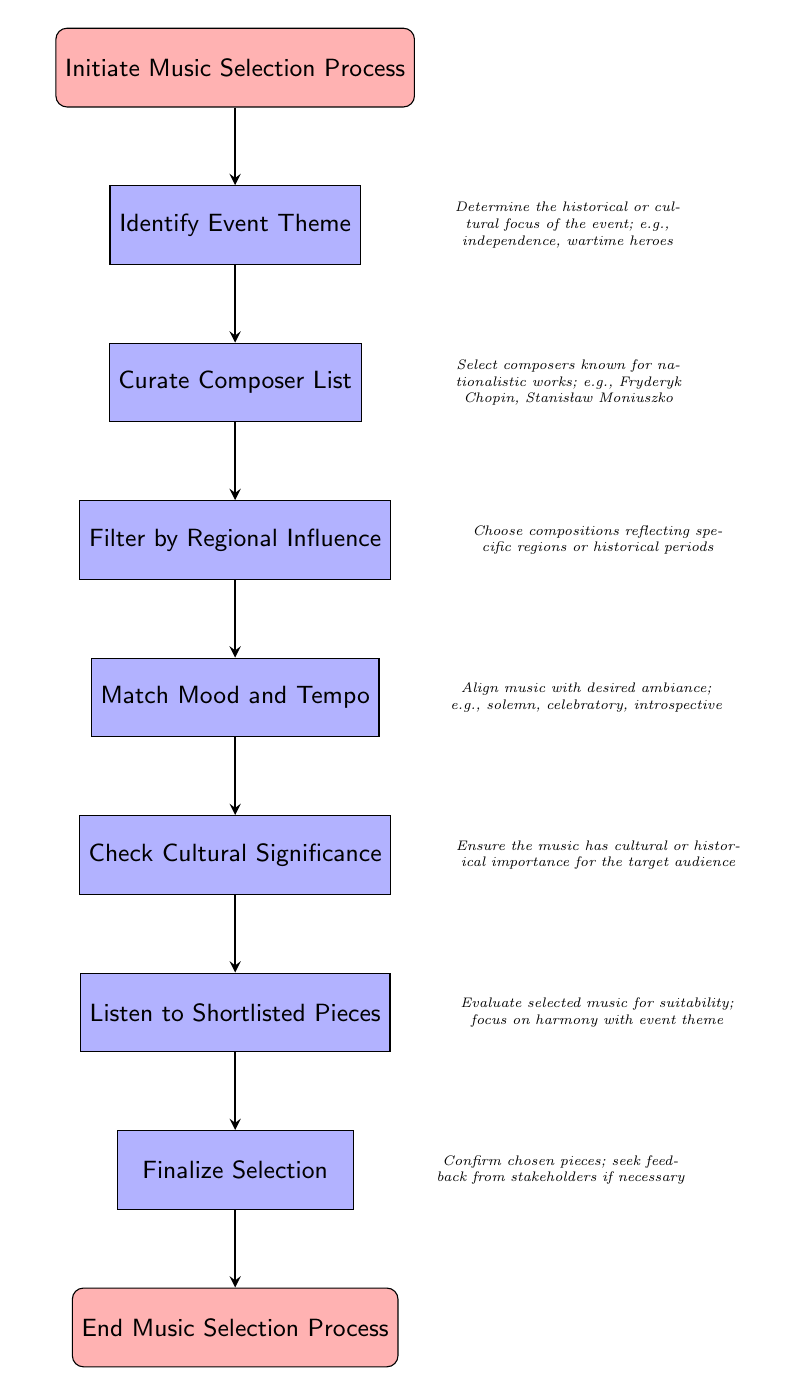What is the starting point of the diagram? The diagram starts with the node titled "Initiate Music Selection Process," which represents the beginning of the process.
Answer: Initiate Music Selection Process How many nodes are there in the diagram? The diagram consists of seven process nodes between the start and end nodes, indicating sequential steps in the music selection process.
Answer: 7 What is the final step in the process? The last node before ending the process is titled "Finalize Selection," confirming the final stage of music selection.
Answer: Finalize Selection Which node follows "Curate Composer List"? The node that follows "Curate Composer List" is "Filter by Regional Influence," representing the next step in choosing music.
Answer: Filter by Regional Influence What is the purpose of the "Check Cultural Significance" node? This node ensures that the selected music holds cultural or historical importance for the specific audience attending the event.
Answer: Ensure cultural importance What are the possible moods mentioned in "Match Mood and Tempo"? The node references moods like solemn, celebratory, and introspective as examples to align the music with the desired ambiance for the event.
Answer: solemn, celebratory, introspective How does the process flow from "Listen to Shortlisted Pieces" to "Finalize Selection"? After evaluating the shortlisted pieces for suitability, the process leads directly to the "Finalize Selection" step, confirming the chosen music.
Answer: Directly Which node comes before the "End Music Selection Process”? The node immediately preceding "End Music Selection Process" is "Finalize Selection," marking the last decision before the conclusion of the overall process.
Answer: Finalize Selection 